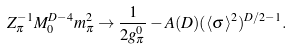<formula> <loc_0><loc_0><loc_500><loc_500>Z _ { \pi } ^ { - 1 } M _ { 0 } ^ { D - 4 } m _ { \pi } ^ { 2 } \rightarrow \frac { 1 } { 2 g _ { \pi } ^ { 0 } } - A ( D ) ( \langle \sigma \rangle ^ { 2 } ) ^ { D / 2 - 1 } .</formula> 